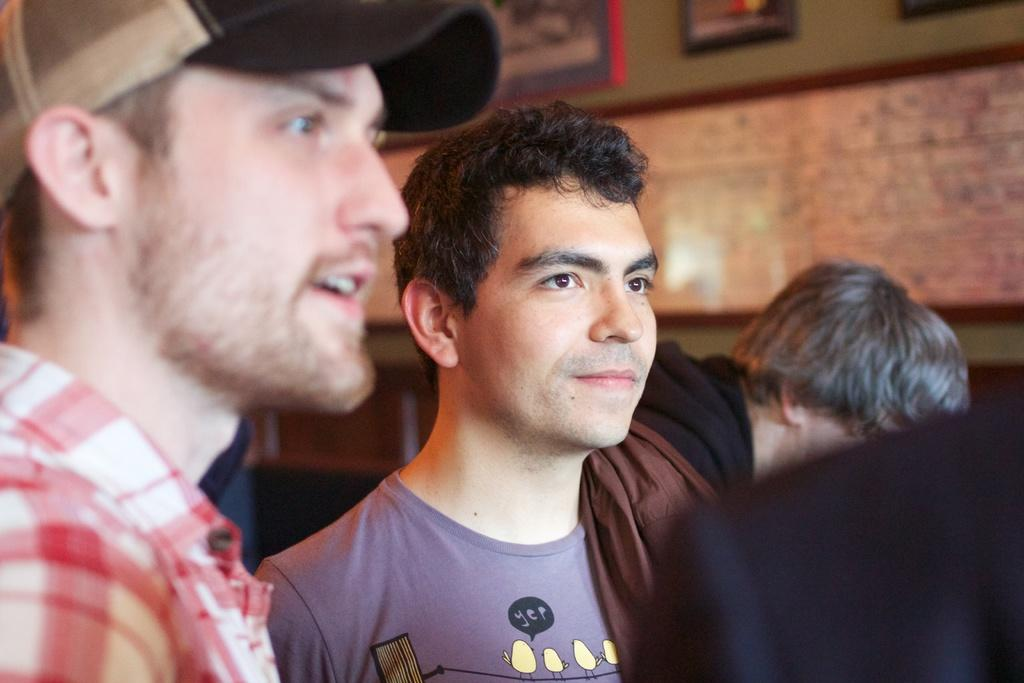Who or what can be seen at the bottom of the image? There are people present at the bottom of the image. What is visible in the background of the image? There is a wall in the background of the image. What is attached to the wall in the image? There are photo frames attached to the wall. What type of behavior can be observed in the wing of the bird in the image? There is no bird or wing present in the image; it only features people and a wall with photo frames. 